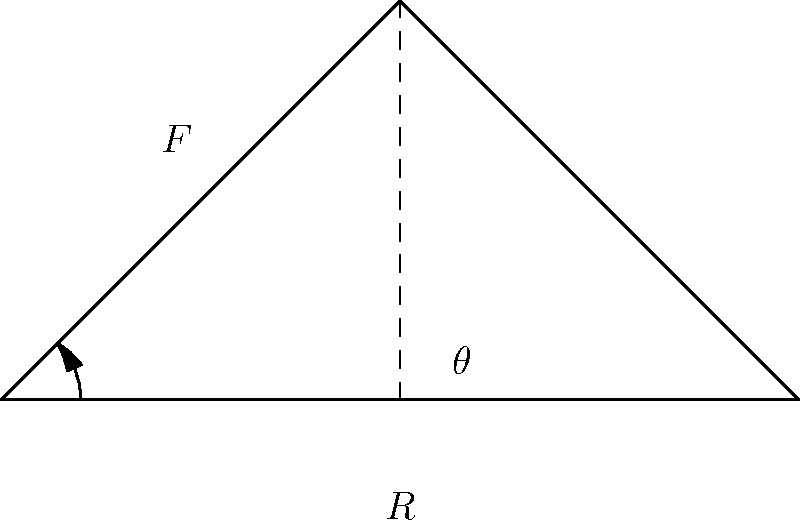In the truss bridge support shown above, what is the optimal angle $\theta$ that minimizes the force $F$ in the diagonal member, given that $R$ is the vertical reaction force at the base? To find the optimal angle that minimizes the force in the diagonal member, we need to follow these steps:

1) The force in the diagonal member $F$ can be expressed in terms of the reaction force $R$ and the angle $\theta$:

   $F = \frac{R}{2\sin\theta}$

2) To minimize $F$, we need to maximize $\sin\theta$ in the denominator.

3) The maximum value of $\sin\theta$ occurs when $\theta = 90°$. However, this would result in a vertical member, which is not practical for a truss.

4) In practice, the optimal angle is a balance between minimizing the force and maintaining a practical structure.

5) It can be shown mathematically that the optimal angle for minimizing both the force in the diagonal member and the horizontal thrust at the base is 45°.

6) At 45°, $\sin\theta = \frac{1}{\sqrt{2}} \approx 0.707$, which is close to the maximum value of 1.

7) This angle also provides a good balance between vertical and horizontal components of the force, distributing the load effectively.
Answer: 45° 